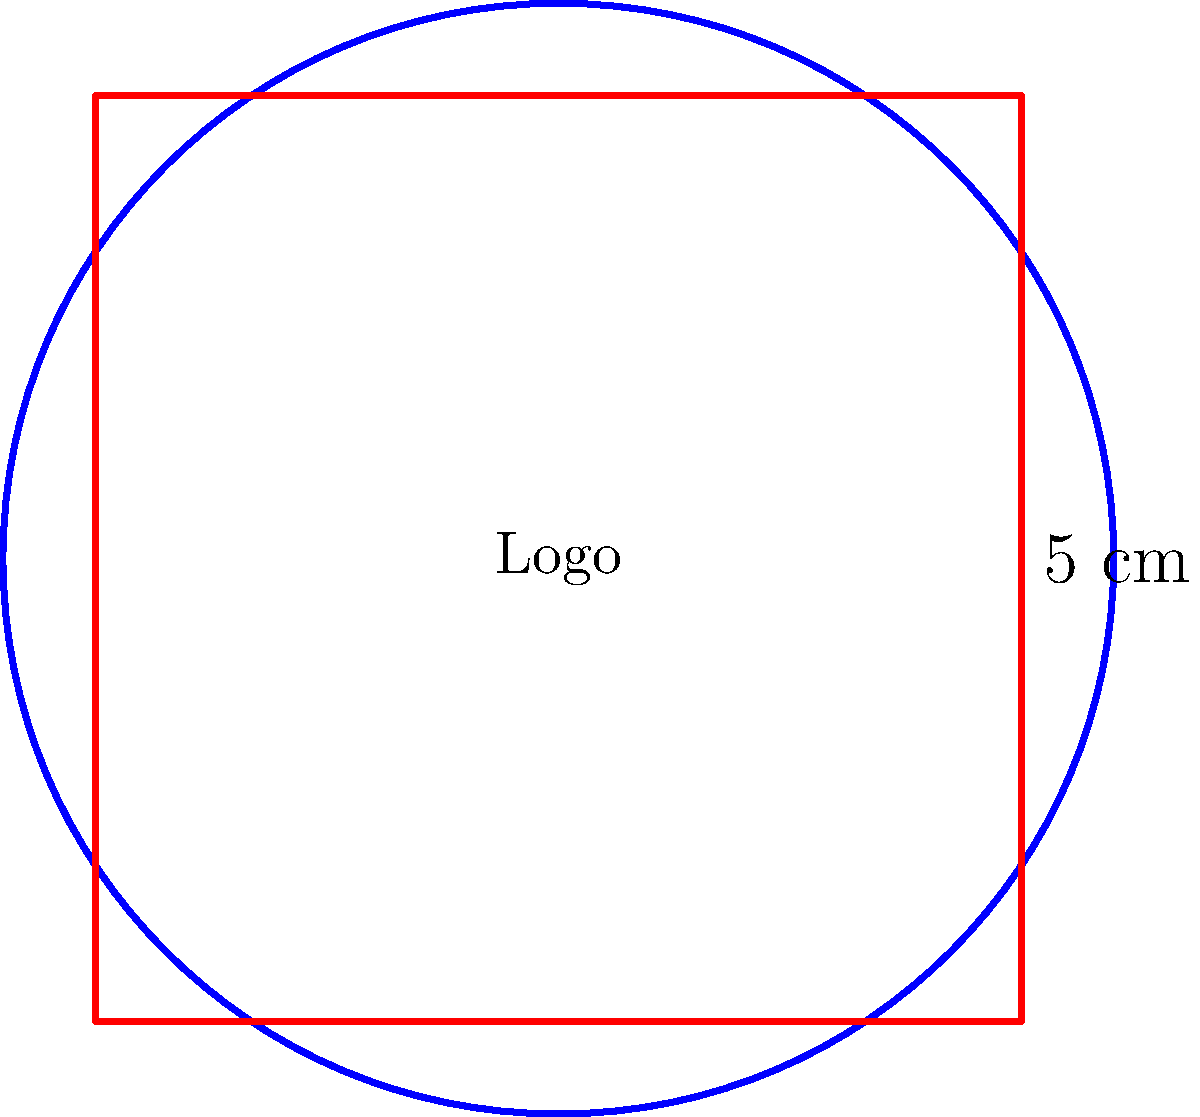A startup company wants to create a circular logo for their brand. The logo will be placed inside a square frame with sides measuring 5 cm. If the logo touches all four sides of the frame, what is the area of the circular logo in square centimeters? Round your answer to two decimal places. Let's break this down into steps:

1. Identify the key information:
   - The frame is a square with sides of 5 cm
   - The logo is a circle that touches all sides of the square

2. Determine the diameter of the circle:
   - The diameter of the circle is equal to the side length of the square
   - Diameter = 5 cm

3. Calculate the radius of the circle:
   - Radius = Diameter ÷ 2
   - Radius = 5 cm ÷ 2 = 2.5 cm

4. Use the formula for the area of a circle:
   - Area = $\pi r^2$
   - Where $r$ is the radius and $\pi$ is approximately 3.14159

5. Plug in the values:
   - Area = $\pi \times (2.5 \text{ cm})^2$
   - Area = $3.14159 \times 6.25 \text{ cm}^2$
   - Area = $19.63494 \text{ cm}^2$

6. Round to two decimal places:
   - Area ≈ 19.63 cm²

Therefore, the area of the circular logo is approximately 19.63 square centimeters.
Answer: 19.63 cm² 